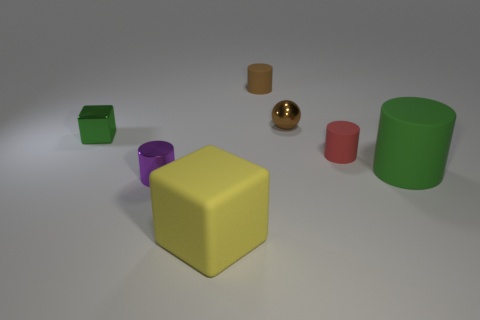Subtract 2 cylinders. How many cylinders are left? 2 Subtract all shiny cylinders. How many cylinders are left? 3 Add 3 green matte balls. How many objects exist? 10 Subtract all cyan cylinders. Subtract all green cubes. How many cylinders are left? 4 Subtract all spheres. How many objects are left? 6 Subtract 1 green blocks. How many objects are left? 6 Subtract all tiny blue balls. Subtract all matte things. How many objects are left? 3 Add 5 red cylinders. How many red cylinders are left? 6 Add 1 shiny things. How many shiny things exist? 4 